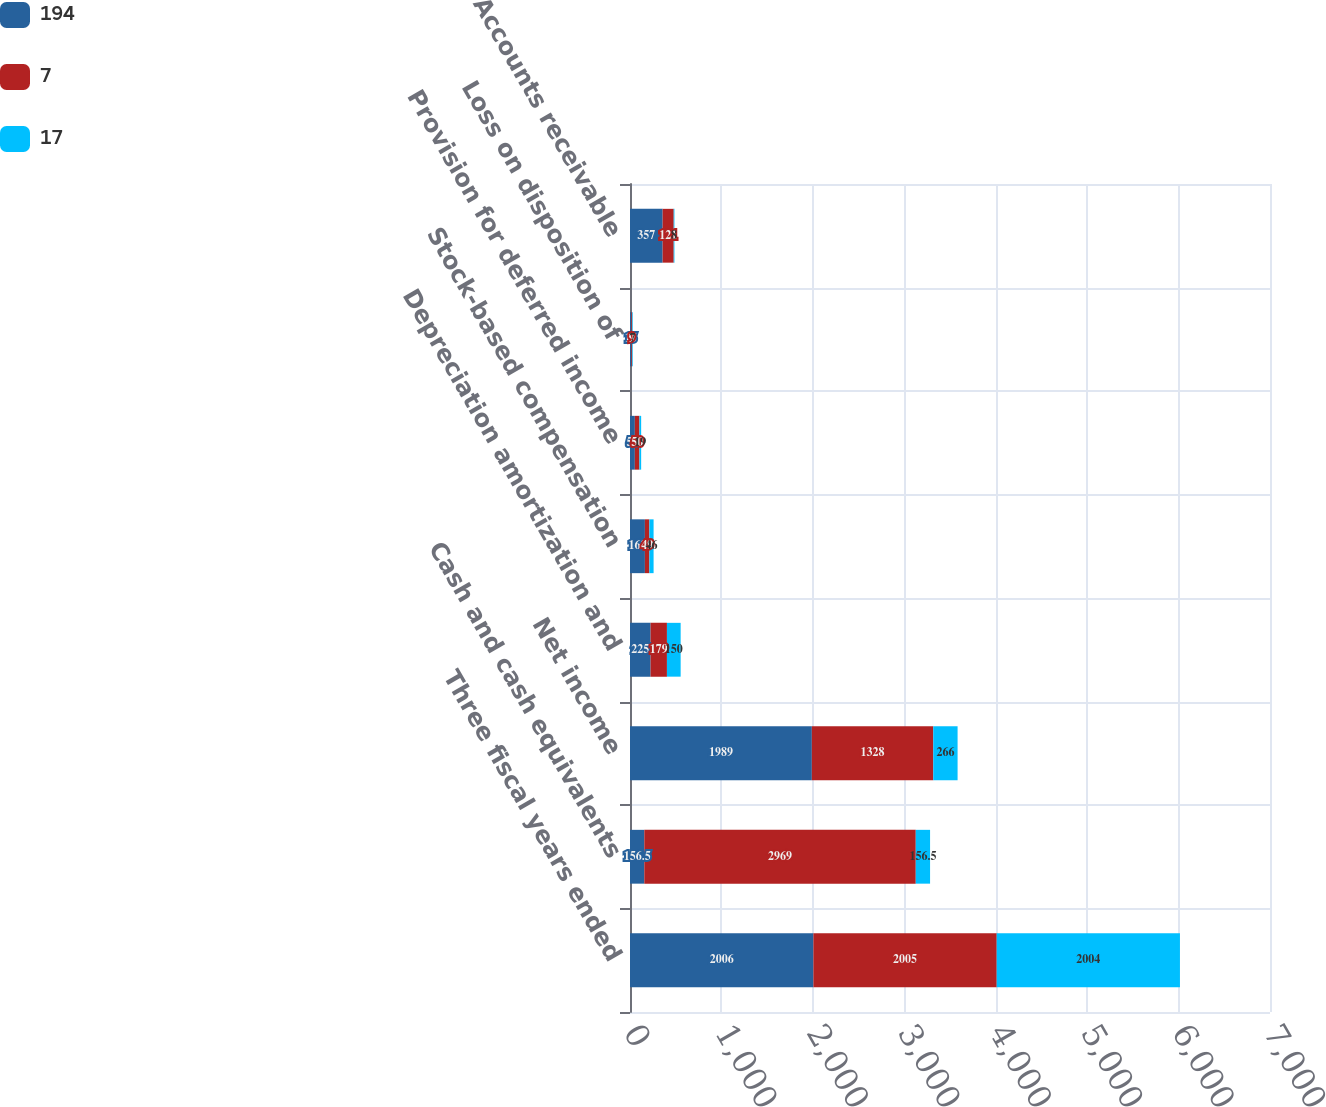<chart> <loc_0><loc_0><loc_500><loc_500><stacked_bar_chart><ecel><fcel>Three fiscal years ended<fcel>Cash and cash equivalents<fcel>Net income<fcel>Depreciation amortization and<fcel>Stock-based compensation<fcel>Provision for deferred income<fcel>Loss on disposition of<fcel>Accounts receivable<nl><fcel>194<fcel>2006<fcel>156.5<fcel>1989<fcel>225<fcel>163<fcel>53<fcel>15<fcel>357<nl><fcel>7<fcel>2005<fcel>2969<fcel>1328<fcel>179<fcel>49<fcel>50<fcel>9<fcel>121<nl><fcel>17<fcel>2004<fcel>156.5<fcel>266<fcel>150<fcel>46<fcel>19<fcel>7<fcel>8<nl></chart> 